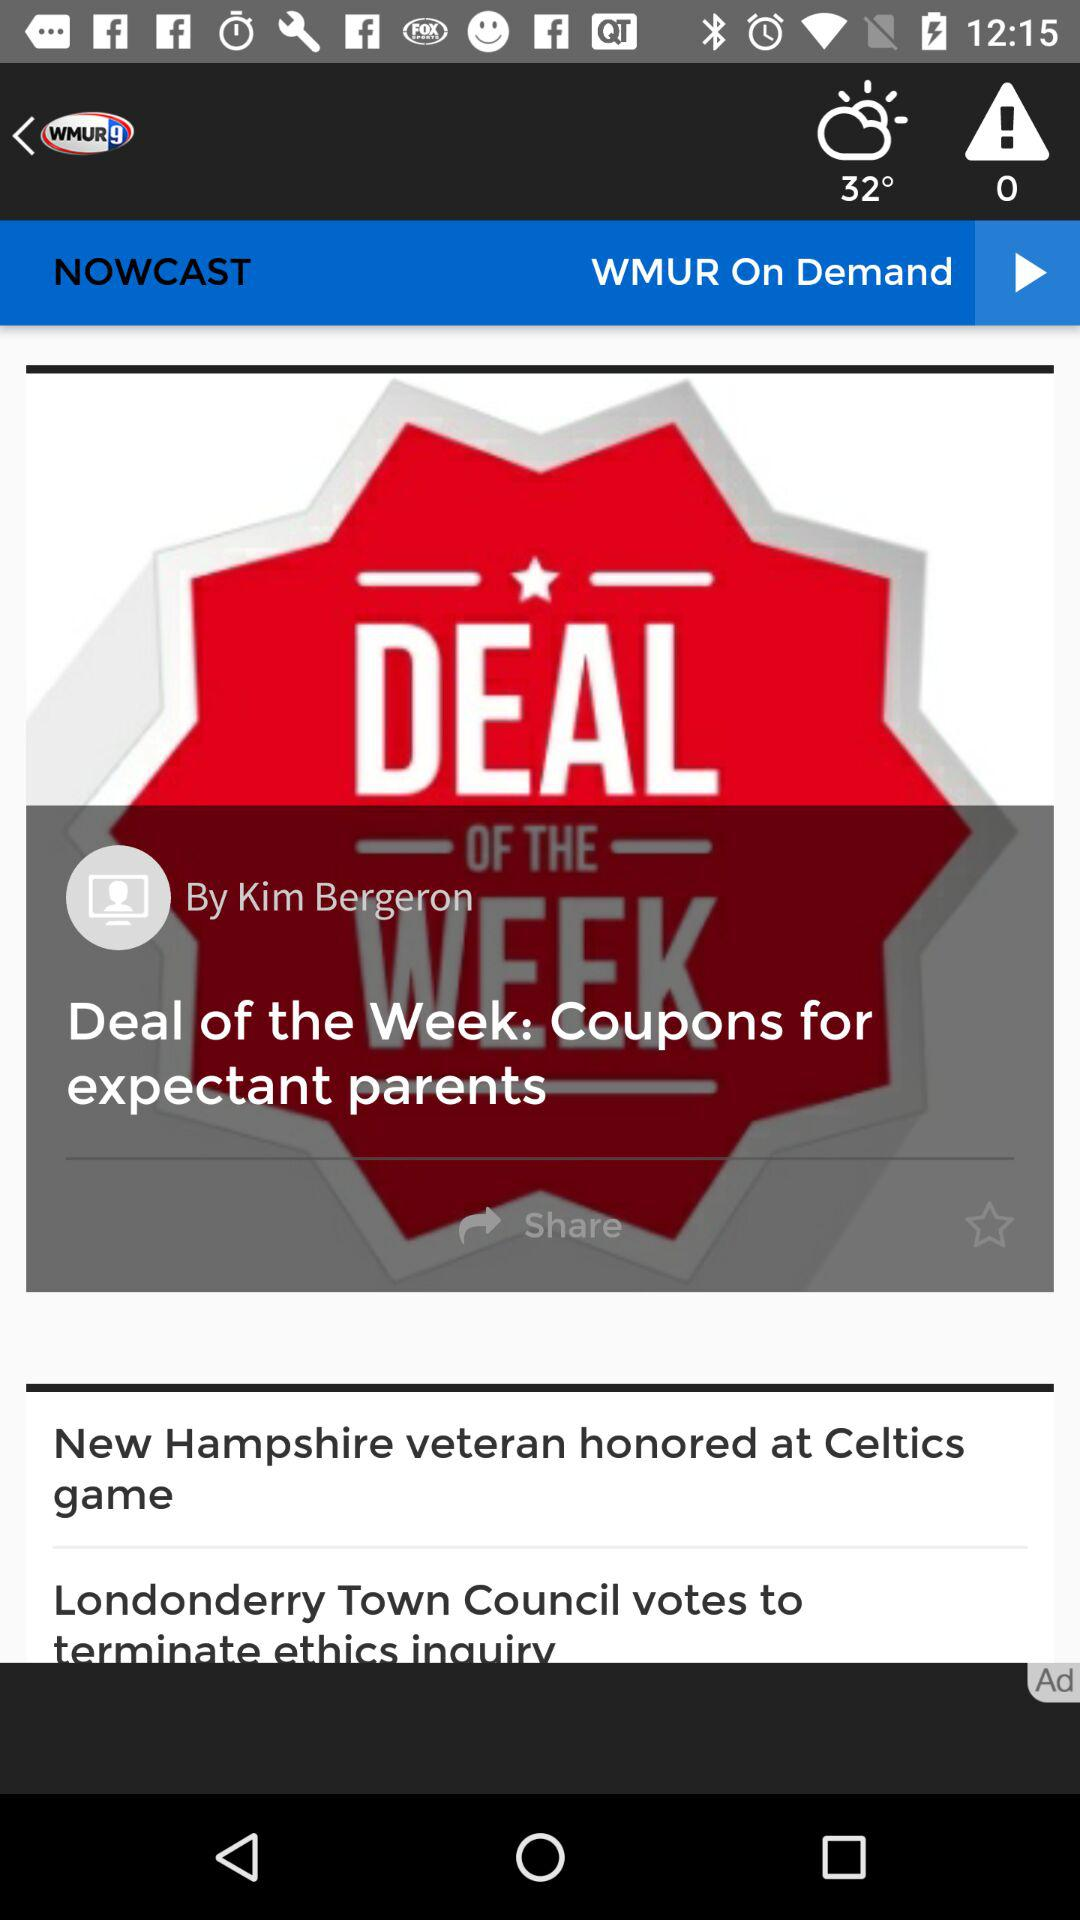What is the temperature? The temperature is 32°. 